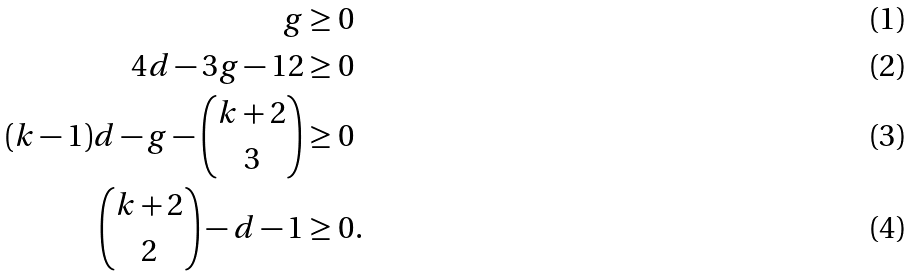<formula> <loc_0><loc_0><loc_500><loc_500>g & \geq 0 \\ 4 d - 3 g - 1 2 & \geq 0 \\ ( k - 1 ) d - g - \binom { k + 2 } { 3 } & \geq 0 \\ \binom { k + 2 } { 2 } - d - 1 & \geq 0 .</formula> 